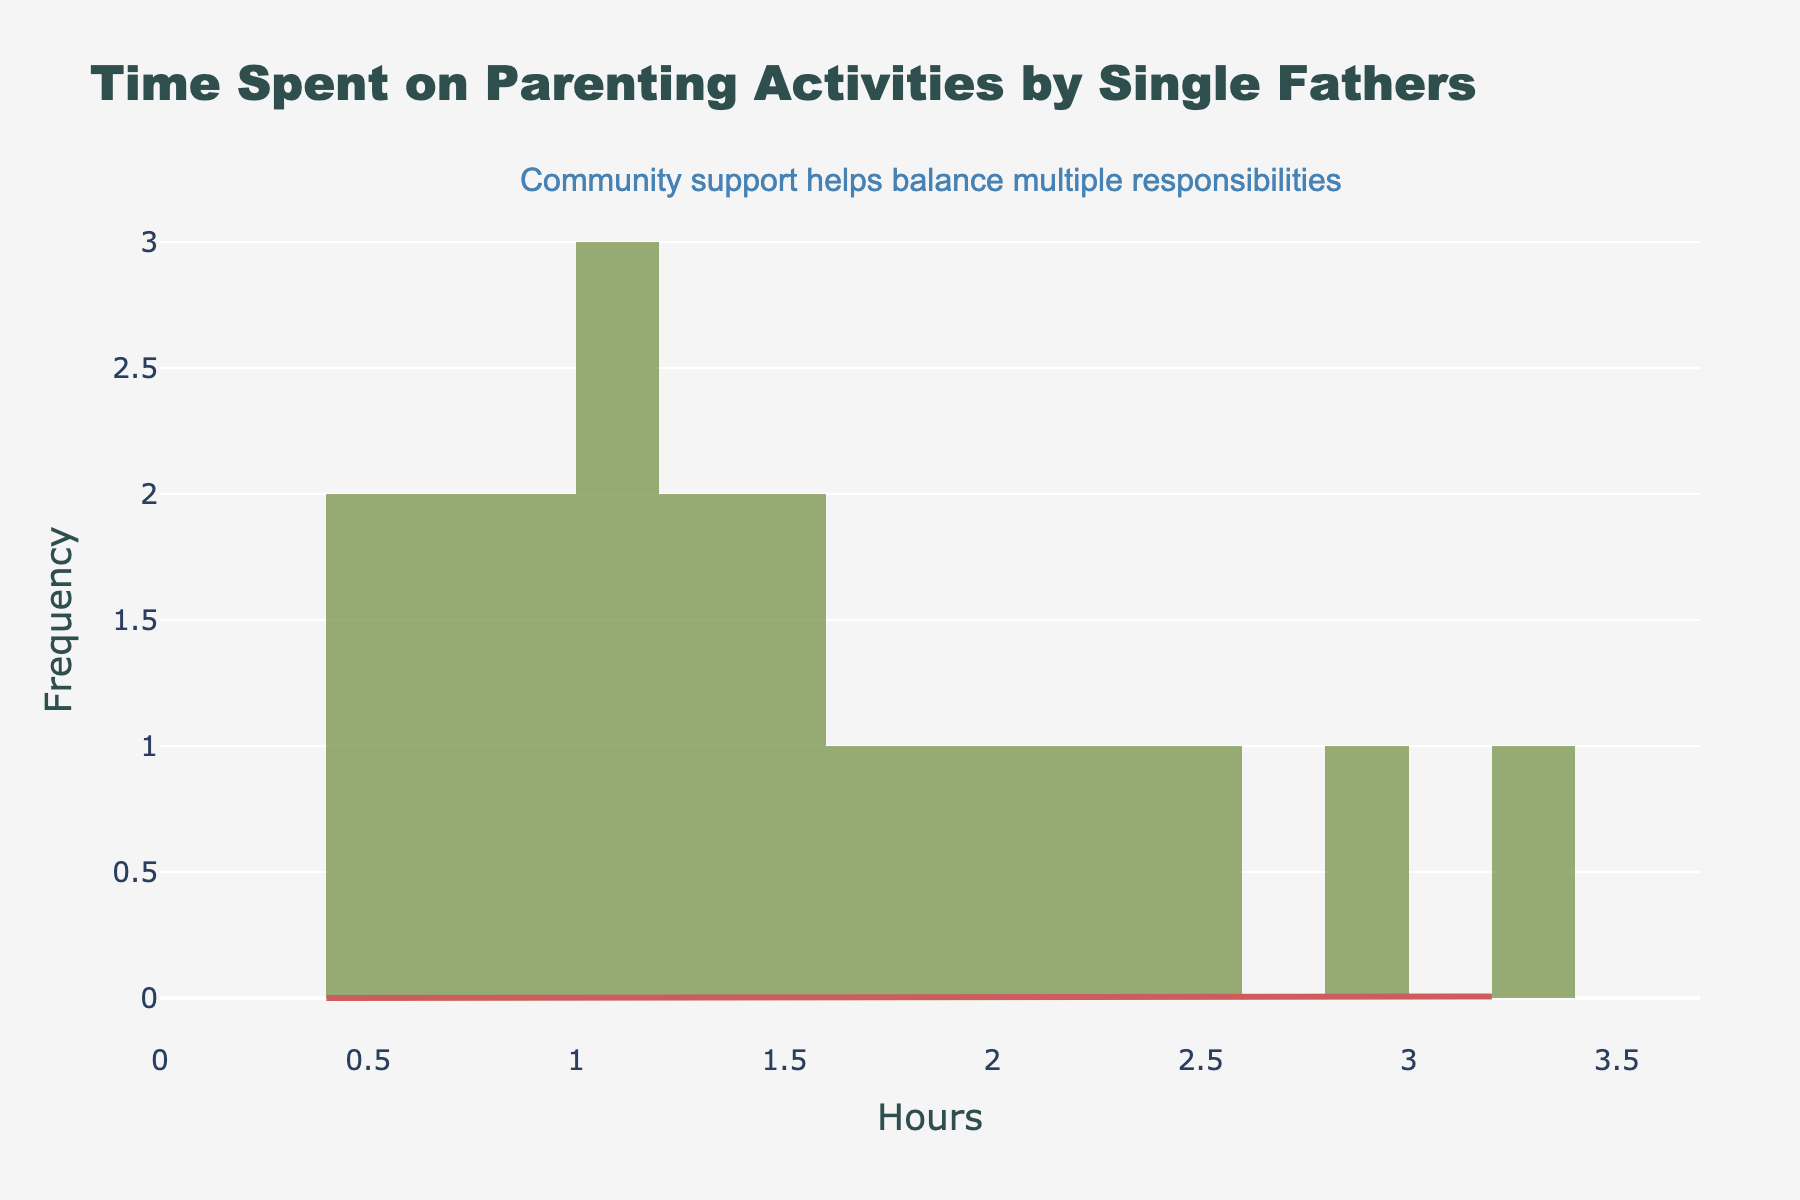What's the title of the figure? Find the text at the top of the figure, which displays the title, "Time Spent on Parenting Activities by Single Fathers".
Answer: Time Spent on Parenting Activities by Single Fathers What is the range of hours spent on parenting activities? Find the minimum and maximum values on the x-axis. The range is from 0 to 3.2.
Answer: 0 to 3.2 hours Which activity is spent the least amount of time on average? Look for the smallest value on the x-axis in the histogram. The smallest value is around 0.4 for Parent-teacher meetings.
Answer: Parent-teacher meetings Which activity has the highest number of hours spent? Observe the highest value on the x-axis. This value corresponds to Playtime at 3.2 hours.
Answer: Playtime What does the KDE (density curve) represent? The KDE (Kernel Density Estimation) shows the probability density function of the hours spent, providing a smooth estimate of the distribution.
Answer: Probability density function of hours spent What is the average amount of time spent on parenting activities? Calculate the mean of the data points given. Summing all hours (approximately 25.5), then dividing by the number of activities (20) results in approximately 1.28 hours.
Answer: 1.28 hours Which activities are below the average amount of time spent? Compare each activity with the average of 1.28 hours. Activities below 1.28 hours are Medical appointments, Parent-teacher meetings, Homework assistance, Bedtime routine, School drop-off/pick-up, Reading together, Bathing/grooming, Discipline and guidance, Shopping for essentials, Financial planning, and Bedtime stories.
Answer: Medical appointments, Parent-teacher meetings, and more At what hour does the peak density occur according to the KDE? Look for the highest point on the KDE curve to determine where the peak occurs. This point is around 1 hour.
Answer: Around 1 hour How many activities have time spent between 1.0 and 2.0 hours? Count the data points that fall within the range from 1.0 to 2.0 hours. These activities are School drop-off/pick-up, Homework assistance, Sports/extracurricular activities, Bathing/grooming, Shopping for essentials, Emotional support, and Teaching life skills -- totaling 7.
Answer: 7 